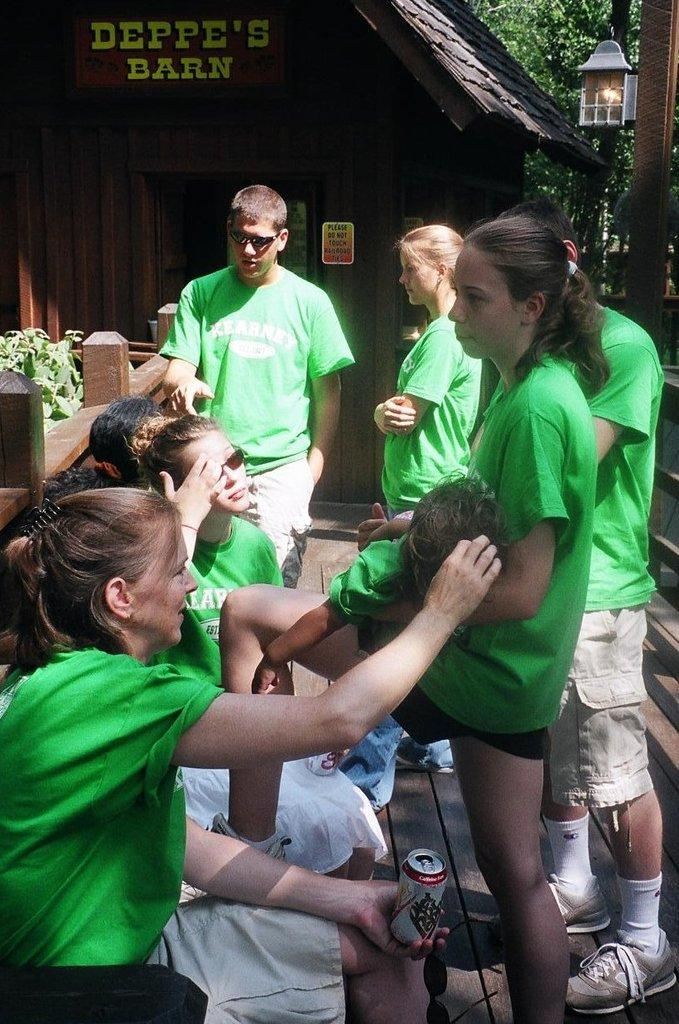What are the people in the image wearing? The people in the image are wearing green t-shirts. What are the people in the image doing? Some of the people are sitting, while others are standing. What can be seen in the background of the image? There is a hut, trees, and a lamp in the background of the image. What is the fence made of in the image? The fence in the image is made of wood. What type of vegetation is present in the image? There are plants in the image. What type of notebook is the pet using to write in the image? There is no pet or notebook present in the image. 